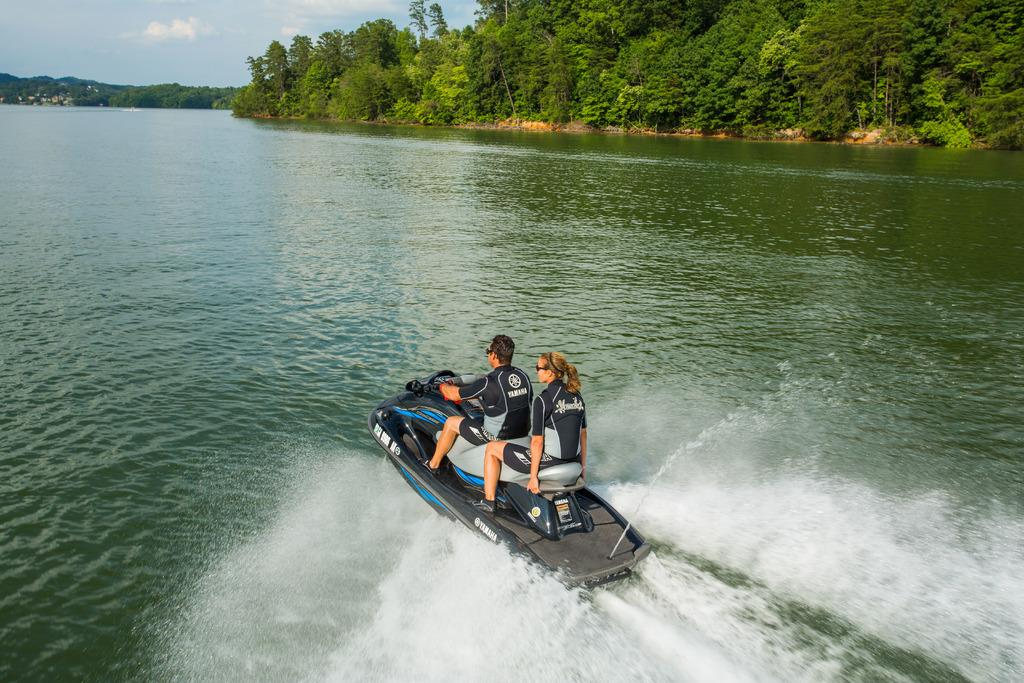Who is present in the image? There is a man and a woman in the image. What are they doing in the image? They are riding a black color boat. Where is the boat located? The boat is on river water. What can be seen in the background of the image? There are trees visible in the background. How many cakes are being served on the yard in the image? There is no mention of cakes or a yard in the image; it features a man and a woman riding a black color boat on river water with trees in the background. 